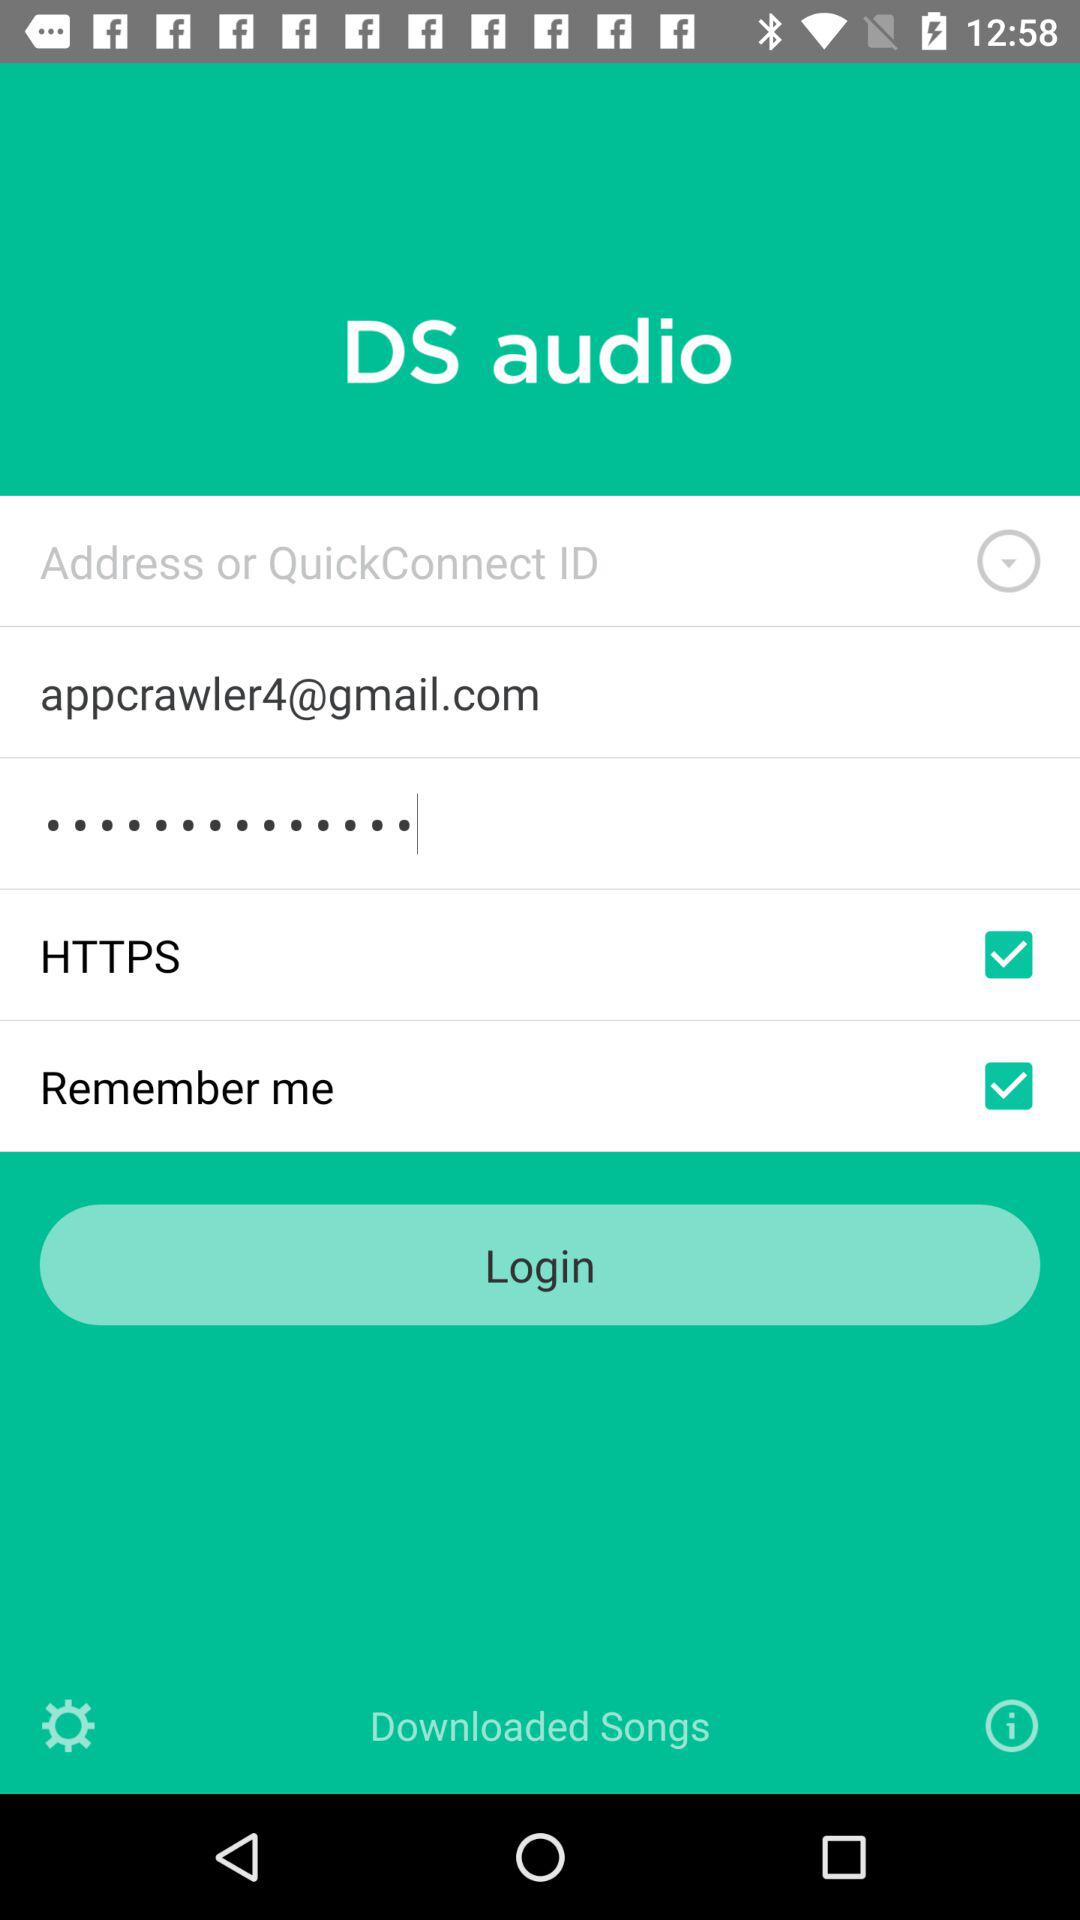What is the status of remember me? The status is on. 